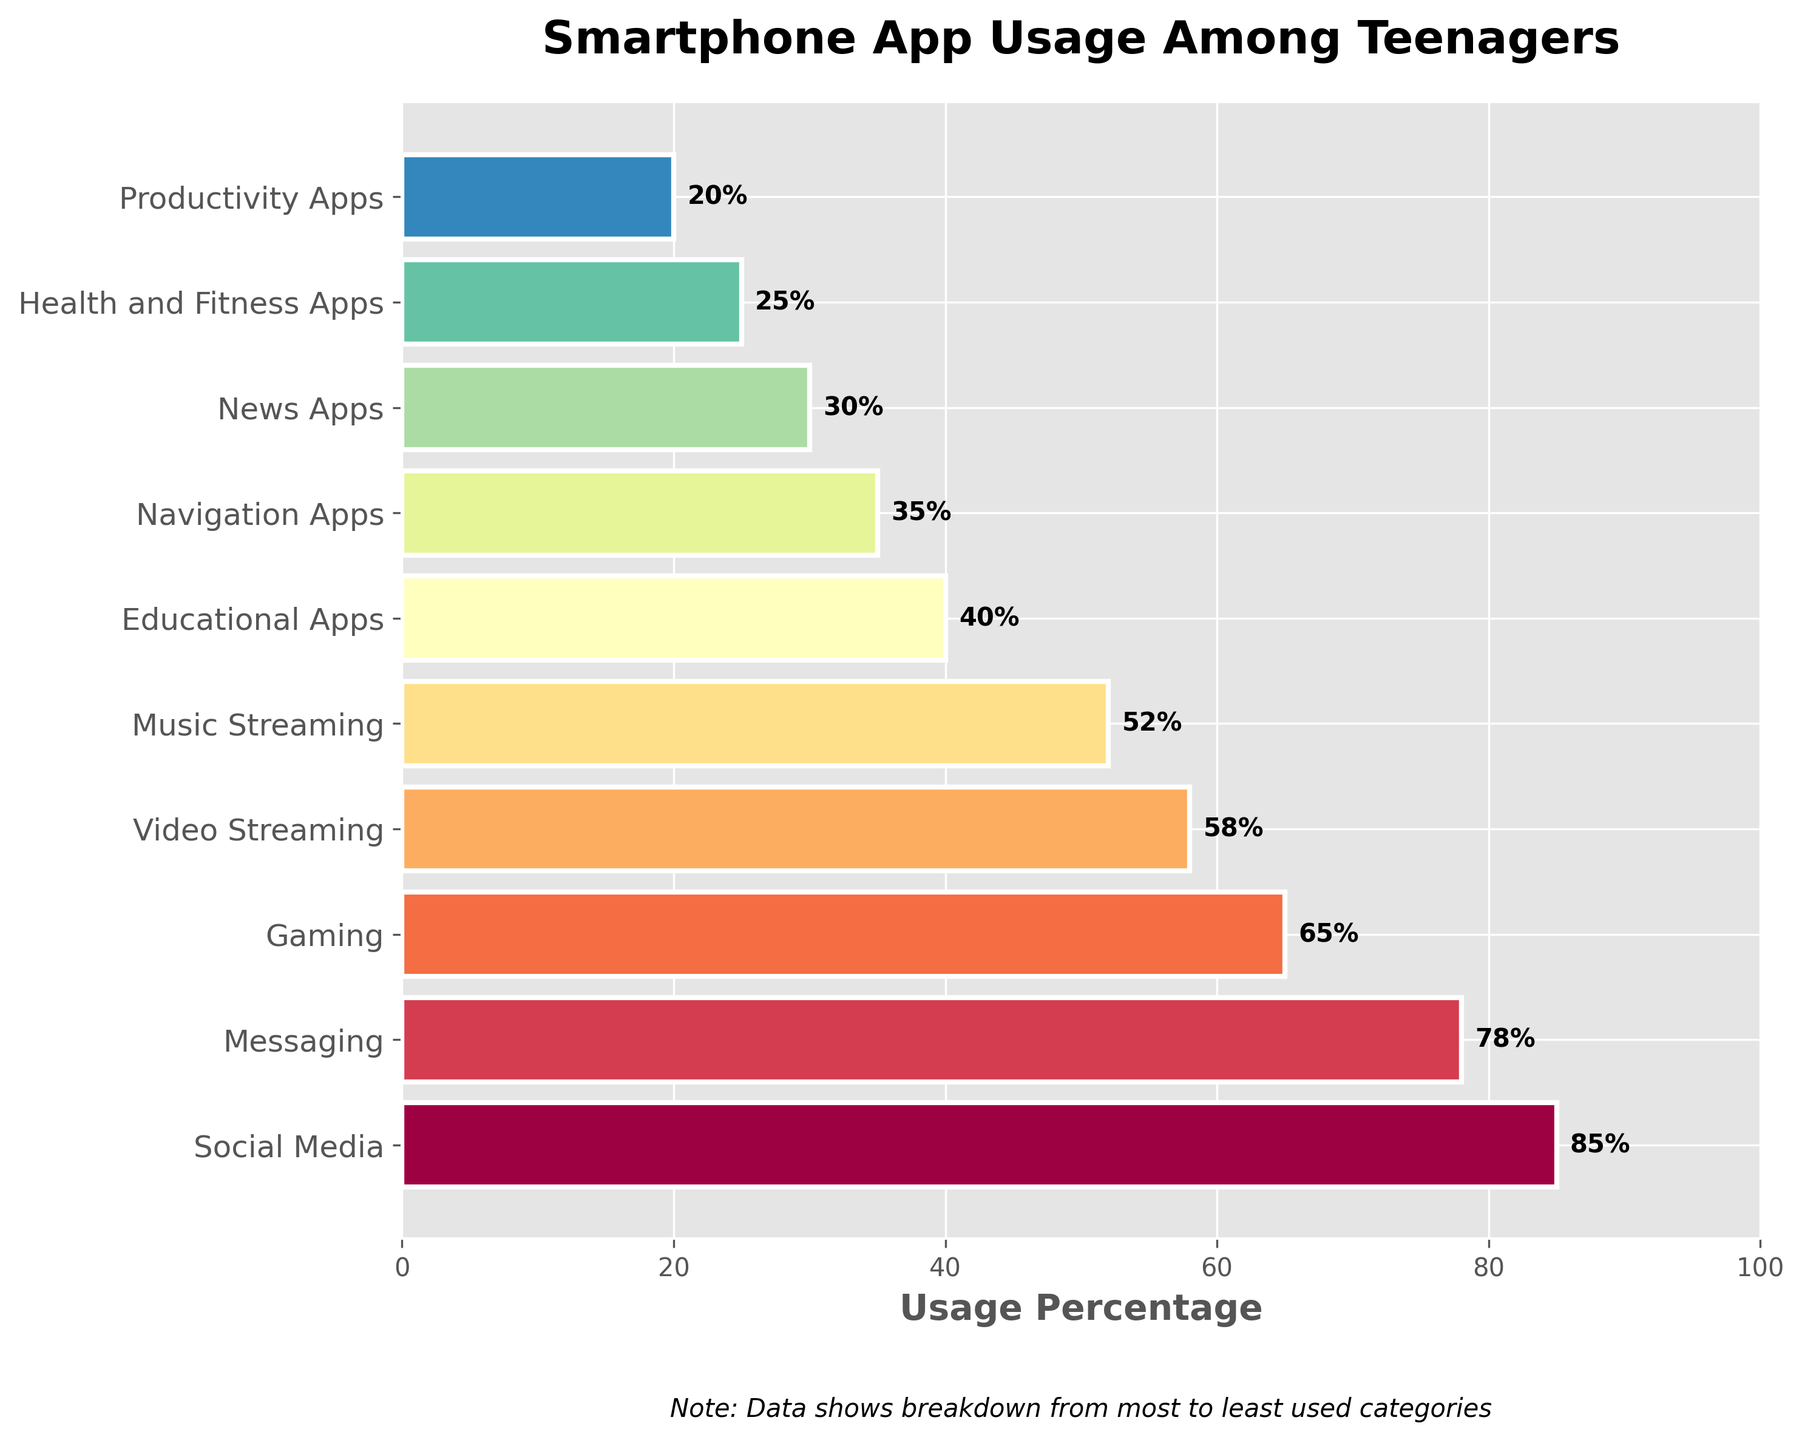Which app category has the highest usage percentage? The highest usage percentage is observed in the Social Media category. It is at the top of the funnel chart and has the largest bar width covering 85%.
Answer: Social Media What is the title of the funnel chart? The title of the chart is usually placed at the top and reads "Smartphone App Usage Among Teenagers" as mentioned in the provided code.
Answer: Smartphone App Usage Among Teenagers How much more usage percentage does Social Media have compared to Messaging? Social Media has a usage percentage of 85%, and Messaging has 78%. The difference is calculated as 85% - 78%.
Answer: 7% What is the combined usage percentage of Video Streaming and Music Streaming apps? The Video Streaming category has a percentage of 58% and Music Streaming has 52%. Adding these together gives 58% + 52%.
Answer: 110% Which category has the lowest usage percentage? The lowest usage percentage displayed at the bottom of the funnel chart is for Productivity Apps at 20%.
Answer: Productivity Apps What is the average usage percentage of the top three categories? The top three categories and their percentages are Social Media (85%), Messaging (78%), and Gaming (65%). To find the average: (85 + 78 + 65) / 3.
Answer: 76% Is the percentage of Educational Apps usage higher than Health and Fitness Apps? Yes, Educational Apps have a usage percentage of 40% while Health and Fitness Apps have 25%, and 40% is greater than 25%.
Answer: Yes Which is more popular among teenagers, Navigation Apps or News Apps? Navigation Apps have a usage percentage of 35% and News Apps have 30%. Therefore, Navigation Apps are more popular as 35% is greater than 30%.
Answer: Navigation Apps How many categories have a usage percentage of 50% or higher? The categories with usage percentages 50% or higher are Social Media (85%), Messaging (78%), Gaming (65%), Video Streaming (58%), and Music Streaming (52%). Counting these gives five categories.
Answer: 5 What is the percentage difference between Gaming and Video Streaming categories? The Gaming category has a usage percentage of 65%, and Video Streaming has 58%. The difference is calculated as 65% - 58%.
Answer: 7% 